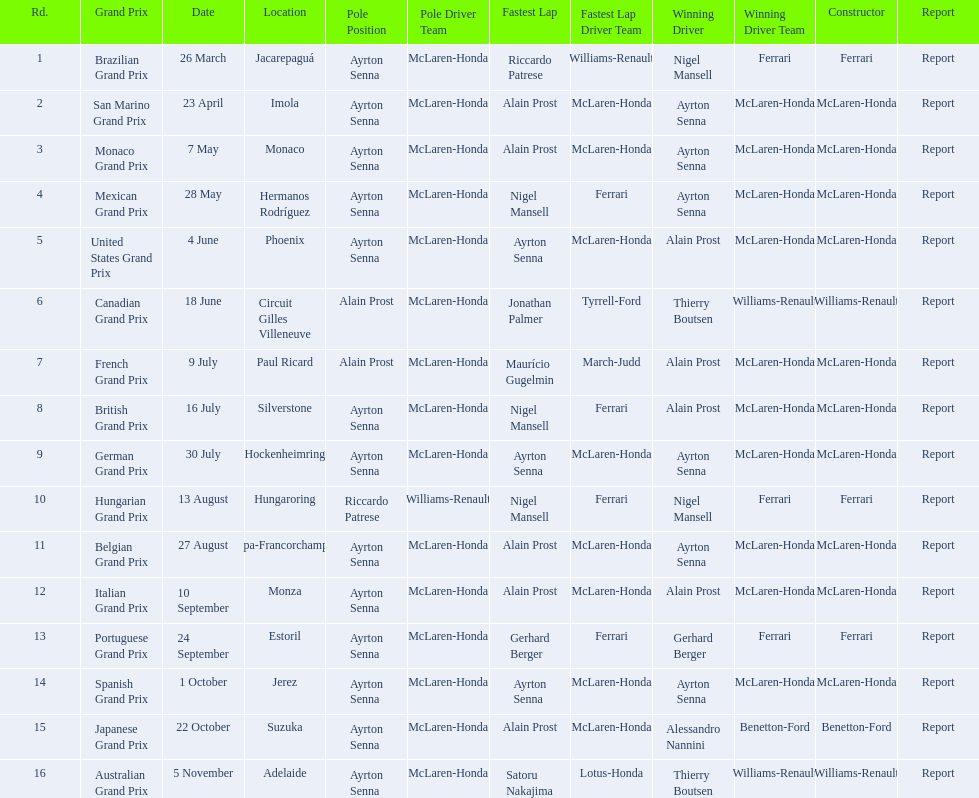What was the only grand prix to be won by benneton-ford? Japanese Grand Prix. 